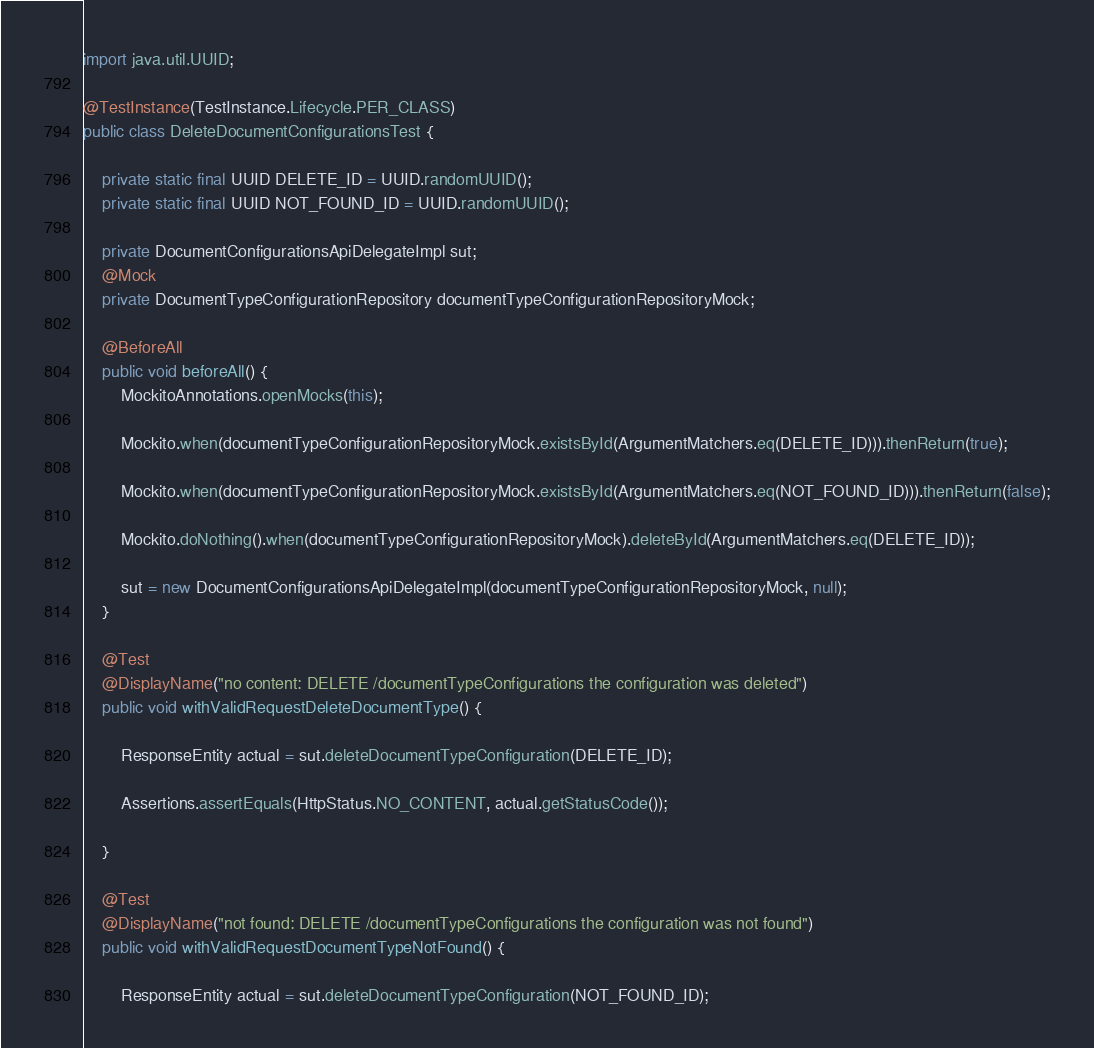Convert code to text. <code><loc_0><loc_0><loc_500><loc_500><_Java_>import java.util.UUID;

@TestInstance(TestInstance.Lifecycle.PER_CLASS)
public class DeleteDocumentConfigurationsTest {

    private static final UUID DELETE_ID = UUID.randomUUID();
    private static final UUID NOT_FOUND_ID = UUID.randomUUID();

    private DocumentConfigurationsApiDelegateImpl sut;
    @Mock
    private DocumentTypeConfigurationRepository documentTypeConfigurationRepositoryMock;

    @BeforeAll
    public void beforeAll() {
        MockitoAnnotations.openMocks(this);

        Mockito.when(documentTypeConfigurationRepositoryMock.existsById(ArgumentMatchers.eq(DELETE_ID))).thenReturn(true);

        Mockito.when(documentTypeConfigurationRepositoryMock.existsById(ArgumentMatchers.eq(NOT_FOUND_ID))).thenReturn(false);

        Mockito.doNothing().when(documentTypeConfigurationRepositoryMock).deleteById(ArgumentMatchers.eq(DELETE_ID));

        sut = new DocumentConfigurationsApiDelegateImpl(documentTypeConfigurationRepositoryMock, null);
    }

    @Test
    @DisplayName("no content: DELETE /documentTypeConfigurations the configuration was deleted")
    public void withValidRequestDeleteDocumentType() {

        ResponseEntity actual = sut.deleteDocumentTypeConfiguration(DELETE_ID);

        Assertions.assertEquals(HttpStatus.NO_CONTENT, actual.getStatusCode());

    }

    @Test
    @DisplayName("not found: DELETE /documentTypeConfigurations the configuration was not found")
    public void withValidRequestDocumentTypeNotFound() {

        ResponseEntity actual = sut.deleteDocumentTypeConfiguration(NOT_FOUND_ID);
</code> 